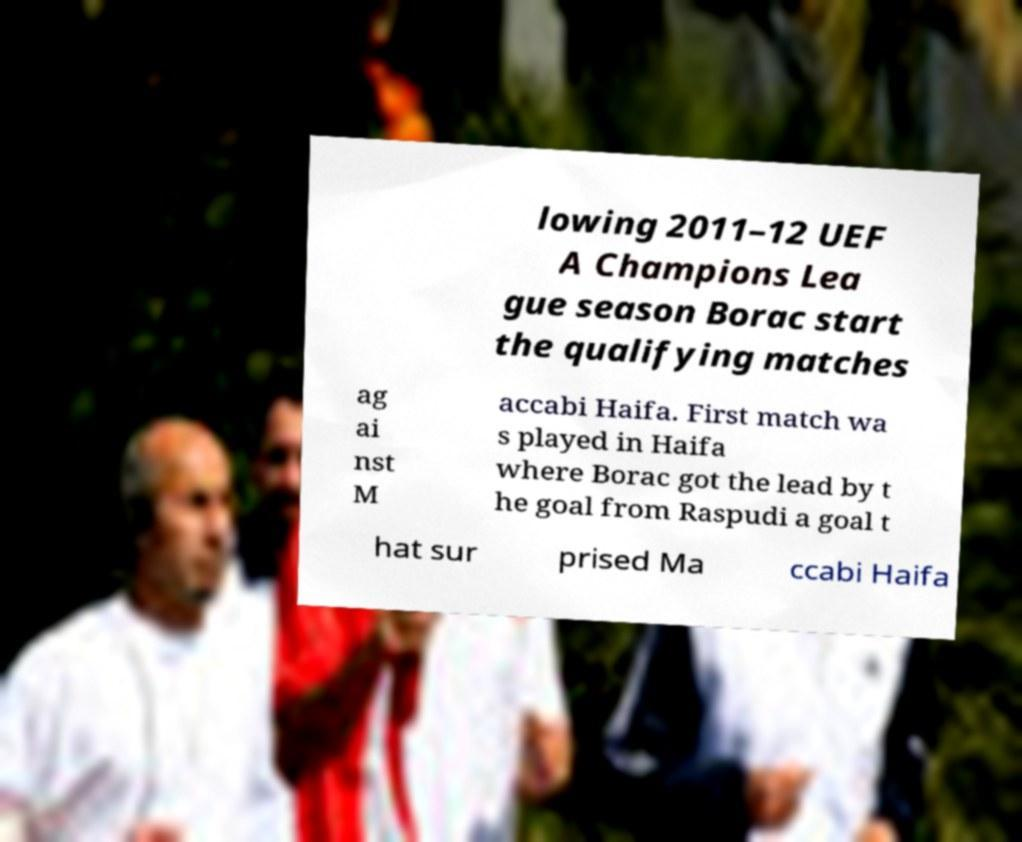For documentation purposes, I need the text within this image transcribed. Could you provide that? lowing 2011–12 UEF A Champions Lea gue season Borac start the qualifying matches ag ai nst M accabi Haifa. First match wa s played in Haifa where Borac got the lead by t he goal from Raspudi a goal t hat sur prised Ma ccabi Haifa 